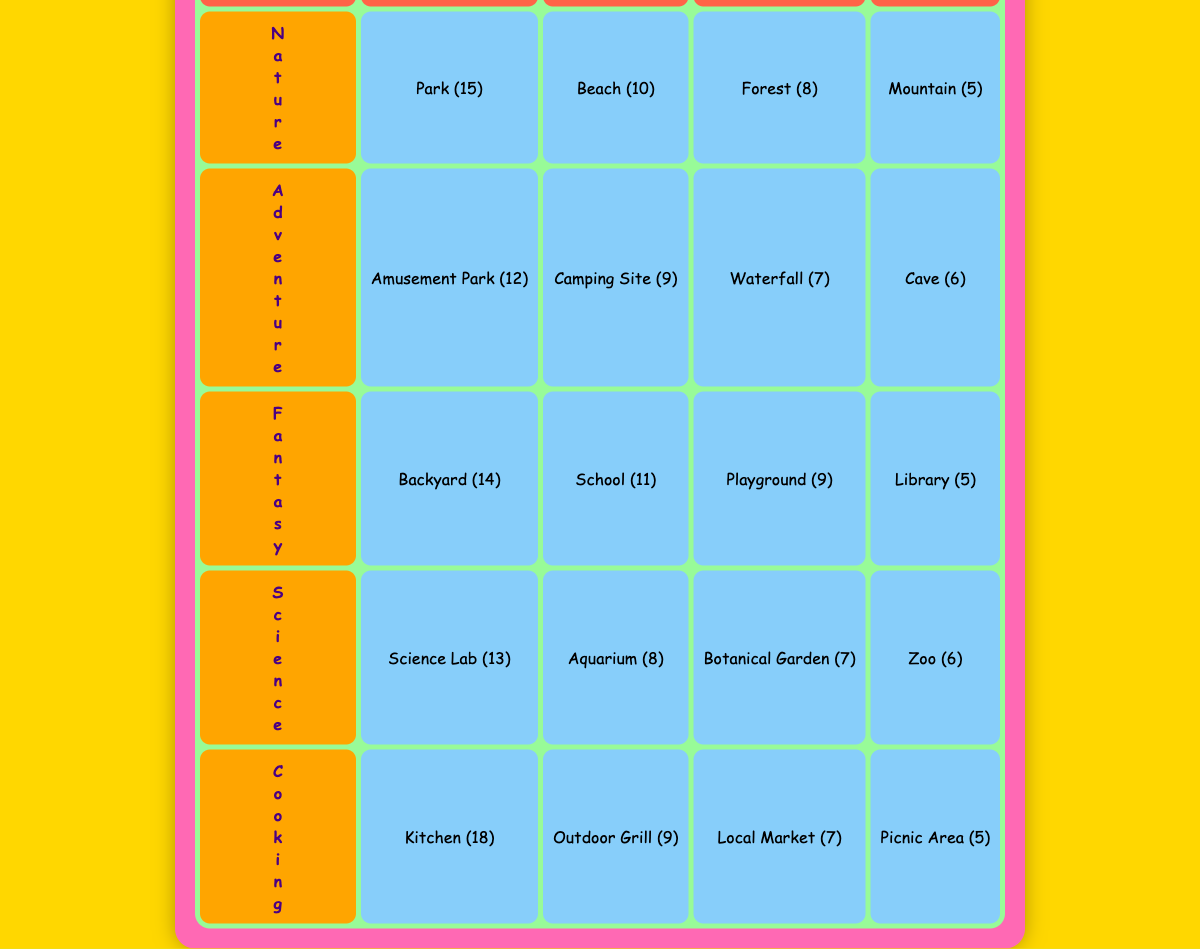What is the most popular filming location for cooking videos? The table shows that the Kitchen has the highest value of 18 for cooking videos, making it the most popular location for this theme.
Answer: Kitchen How many filming locations are used for adventure videos? There are four locations listed under the Adventure theme: Amusement Park, Camping Site, Waterfall, and Cave.
Answer: Four Which nature location has the least number of video themes? The Mountain is listed with the least number of themes, having a value of 5.
Answer: Mountain What is the total number of videos filmed in parks? The only location under Nature is Park with 15 videos. So, the total is 15.
Answer: 15 What is the average number of videos for fantasy locations? The values for fantasy locations are 14, 11, 9, and 5. The total is (14 + 11 + 9 + 5) = 39, and the average is 39/4 = 9.75.
Answer: 9.75 Is the number of videos for science locations higher than adventure locations? The total for science locations is (13 + 6 + 8 + 7) = 34, and for adventure locations, it is (12 + 9 + 7 + 6) = 34. Since both totals are equal, the answer is no.
Answer: No Which cooking location has the highest count, and how many videos does it have? Looking at the cooking theme, the Kitchen location has the highest count with a value of 18.
Answer: Kitchen, 18 If we compare the total counts of Nature and Cooking locations, which one is larger? The total for Nature locations is (15 + 10 + 8 + 5) = 38, while for Cooking, it is (18 + 9 + 5 + 7) = 39. Cooking has the larger total by 1.
Answer: Cooking What is the difference in video counts between the Backyard and the Camping Site? The Backyard has a count of 14, while the Camping Site has a count of 9. The difference is 14 - 9 = 5.
Answer: 5 